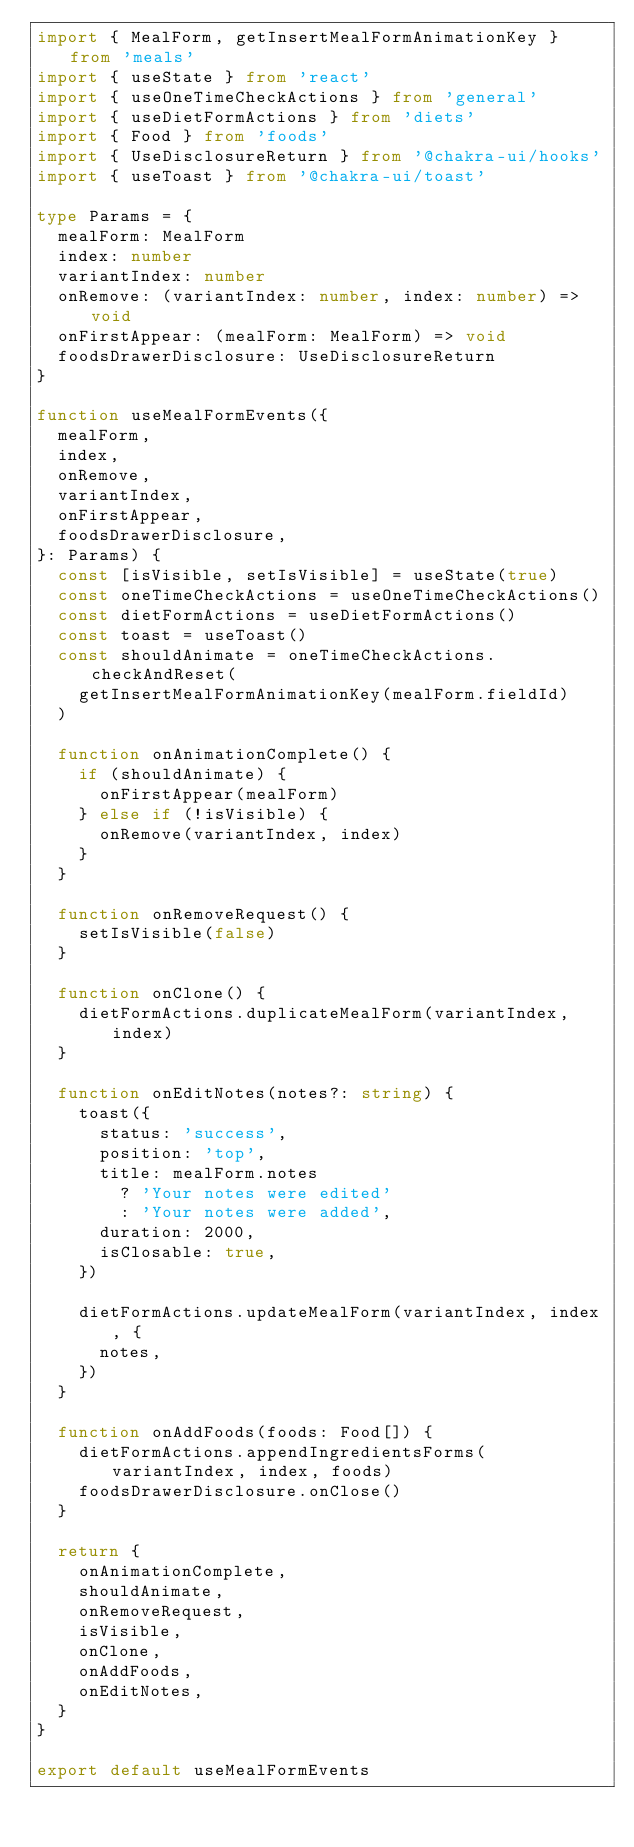<code> <loc_0><loc_0><loc_500><loc_500><_TypeScript_>import { MealForm, getInsertMealFormAnimationKey } from 'meals'
import { useState } from 'react'
import { useOneTimeCheckActions } from 'general'
import { useDietFormActions } from 'diets'
import { Food } from 'foods'
import { UseDisclosureReturn } from '@chakra-ui/hooks'
import { useToast } from '@chakra-ui/toast'

type Params = {
  mealForm: MealForm
  index: number
  variantIndex: number
  onRemove: (variantIndex: number, index: number) => void
  onFirstAppear: (mealForm: MealForm) => void
  foodsDrawerDisclosure: UseDisclosureReturn
}

function useMealFormEvents({
  mealForm,
  index,
  onRemove,
  variantIndex,
  onFirstAppear,
  foodsDrawerDisclosure,
}: Params) {
  const [isVisible, setIsVisible] = useState(true)
  const oneTimeCheckActions = useOneTimeCheckActions()
  const dietFormActions = useDietFormActions()
  const toast = useToast()
  const shouldAnimate = oneTimeCheckActions.checkAndReset(
    getInsertMealFormAnimationKey(mealForm.fieldId)
  )

  function onAnimationComplete() {
    if (shouldAnimate) {
      onFirstAppear(mealForm)
    } else if (!isVisible) {
      onRemove(variantIndex, index)
    }
  }

  function onRemoveRequest() {
    setIsVisible(false)
  }

  function onClone() {
    dietFormActions.duplicateMealForm(variantIndex, index)
  }

  function onEditNotes(notes?: string) {
    toast({
      status: 'success',
      position: 'top',
      title: mealForm.notes
        ? 'Your notes were edited'
        : 'Your notes were added',
      duration: 2000,
      isClosable: true,
    })

    dietFormActions.updateMealForm(variantIndex, index, {
      notes,
    })
  }

  function onAddFoods(foods: Food[]) {
    dietFormActions.appendIngredientsForms(variantIndex, index, foods)
    foodsDrawerDisclosure.onClose()
  }

  return {
    onAnimationComplete,
    shouldAnimate,
    onRemoveRequest,
    isVisible,
    onClone,
    onAddFoods,
    onEditNotes,
  }
}

export default useMealFormEvents
</code> 